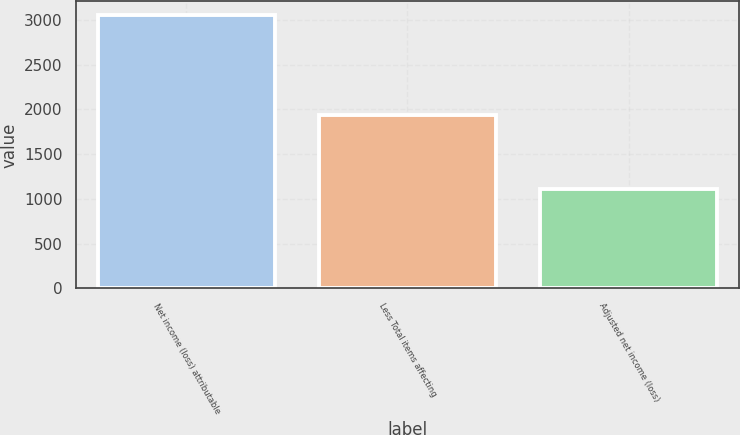Convert chart. <chart><loc_0><loc_0><loc_500><loc_500><bar_chart><fcel>Net income (loss) attributable<fcel>Less Total items affecting<fcel>Adjusted net income (loss)<nl><fcel>3056<fcel>1943<fcel>1113<nl></chart> 